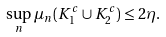Convert formula to latex. <formula><loc_0><loc_0><loc_500><loc_500>\sup _ { n } \mu _ { n } ( K _ { 1 } ^ { c } \cup K _ { 2 } ^ { c } ) \leq 2 \eta .</formula> 